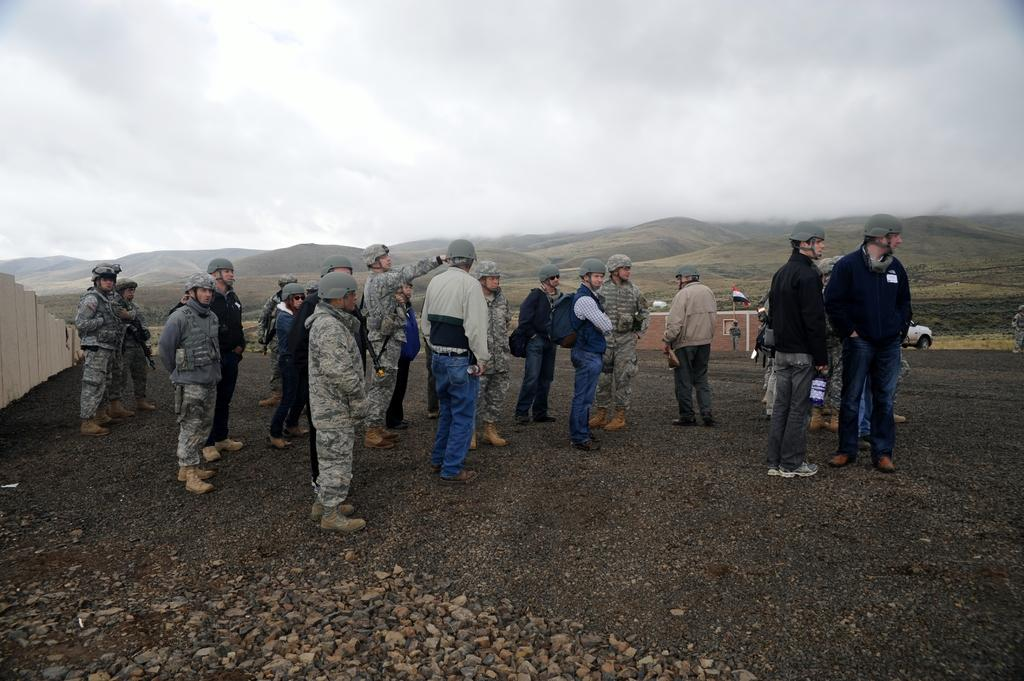What are the people in the image doing? The people in the image are standing on the ground. What type of natural feature can be seen in the image? There are mountains in the image. What object is present in the image that represents a country or organization? There is a flag in the image. What mode of transportation is visible in the image? There is a vehicle in the image. What architectural feature can be seen in the image? There is a wall in the image. What is visible in the background of the image? The sky with clouds is visible in the background of the image. How many eggs are being used to quiet the quivering vehicle in the image? There are no eggs or quivering vehicles present in the image. 